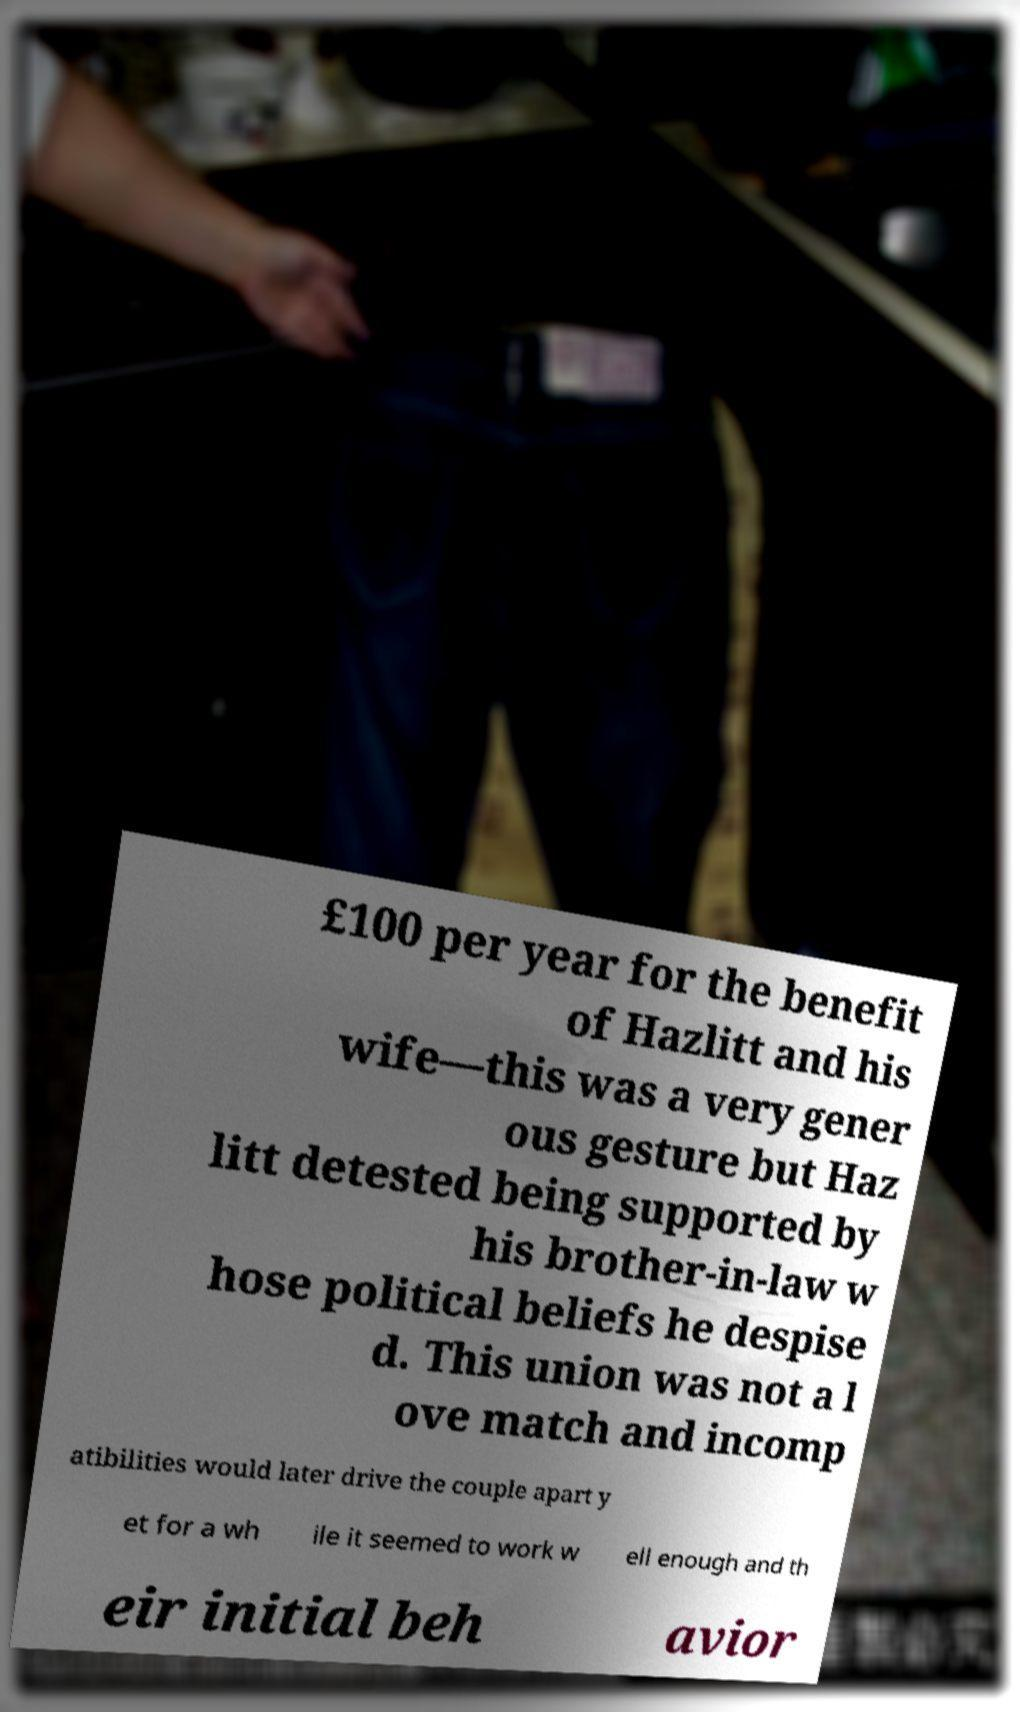Please identify and transcribe the text found in this image. £100 per year for the benefit of Hazlitt and his wife—this was a very gener ous gesture but Haz litt detested being supported by his brother-in-law w hose political beliefs he despise d. This union was not a l ove match and incomp atibilities would later drive the couple apart y et for a wh ile it seemed to work w ell enough and th eir initial beh avior 